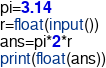<code> <loc_0><loc_0><loc_500><loc_500><_Python_>pi=3.14
r=float(input())
ans=pi*2*r
print(float(ans))</code> 